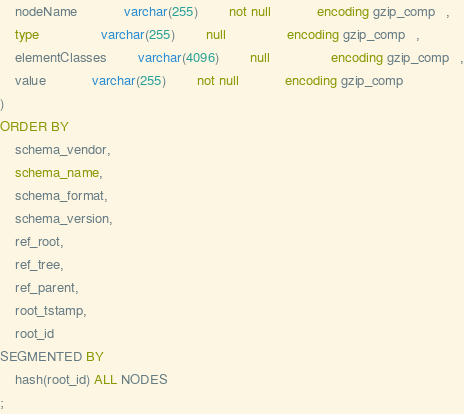Convert code to text. <code><loc_0><loc_0><loc_500><loc_500><_SQL_>	nodeName    		varchar(255)		not null    		encoding gzip_comp   ,
	type        		varchar(255)		null        		encoding gzip_comp   ,
	elementClasses		varchar(4096)		null        		encoding gzip_comp   ,
	value       		varchar(255)		not null    		encoding gzip_comp   
)
ORDER BY
	schema_vendor,
	schema_name,
	schema_format,
	schema_version,
	ref_root,
	ref_tree,
	ref_parent,
	root_tstamp,
	root_id
SEGMENTED BY
	hash(root_id) ALL NODES
;</code> 